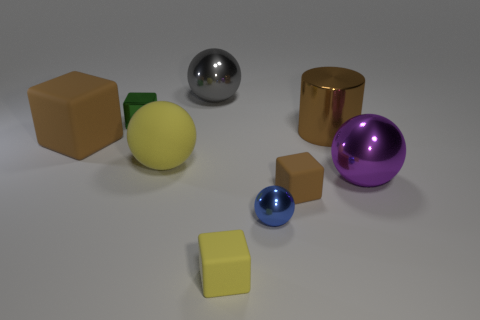What number of metallic things are either large purple objects or small brown things?
Provide a succinct answer. 1. Is there anything else that has the same material as the big purple sphere?
Provide a short and direct response. Yes. Are there any yellow matte objects on the right side of the shiny thing that is behind the tiny green metal object?
Offer a very short reply. Yes. How many things are either spheres behind the blue object or tiny blocks that are to the left of the tiny blue shiny sphere?
Provide a short and direct response. 5. Is there anything else that is the same color as the big metal cylinder?
Your response must be concise. Yes. What color is the large thing that is on the left side of the small object behind the large brown object that is to the left of the brown metallic object?
Your answer should be very brief. Brown. What size is the brown rubber cube to the left of the large metallic thing that is to the left of the small yellow matte block?
Provide a short and direct response. Large. What material is the big object that is to the left of the big purple sphere and on the right side of the blue metallic sphere?
Offer a terse response. Metal. There is a green metal thing; is its size the same as the brown matte block that is in front of the purple ball?
Your response must be concise. Yes. Are any tiny yellow things visible?
Give a very brief answer. Yes. 